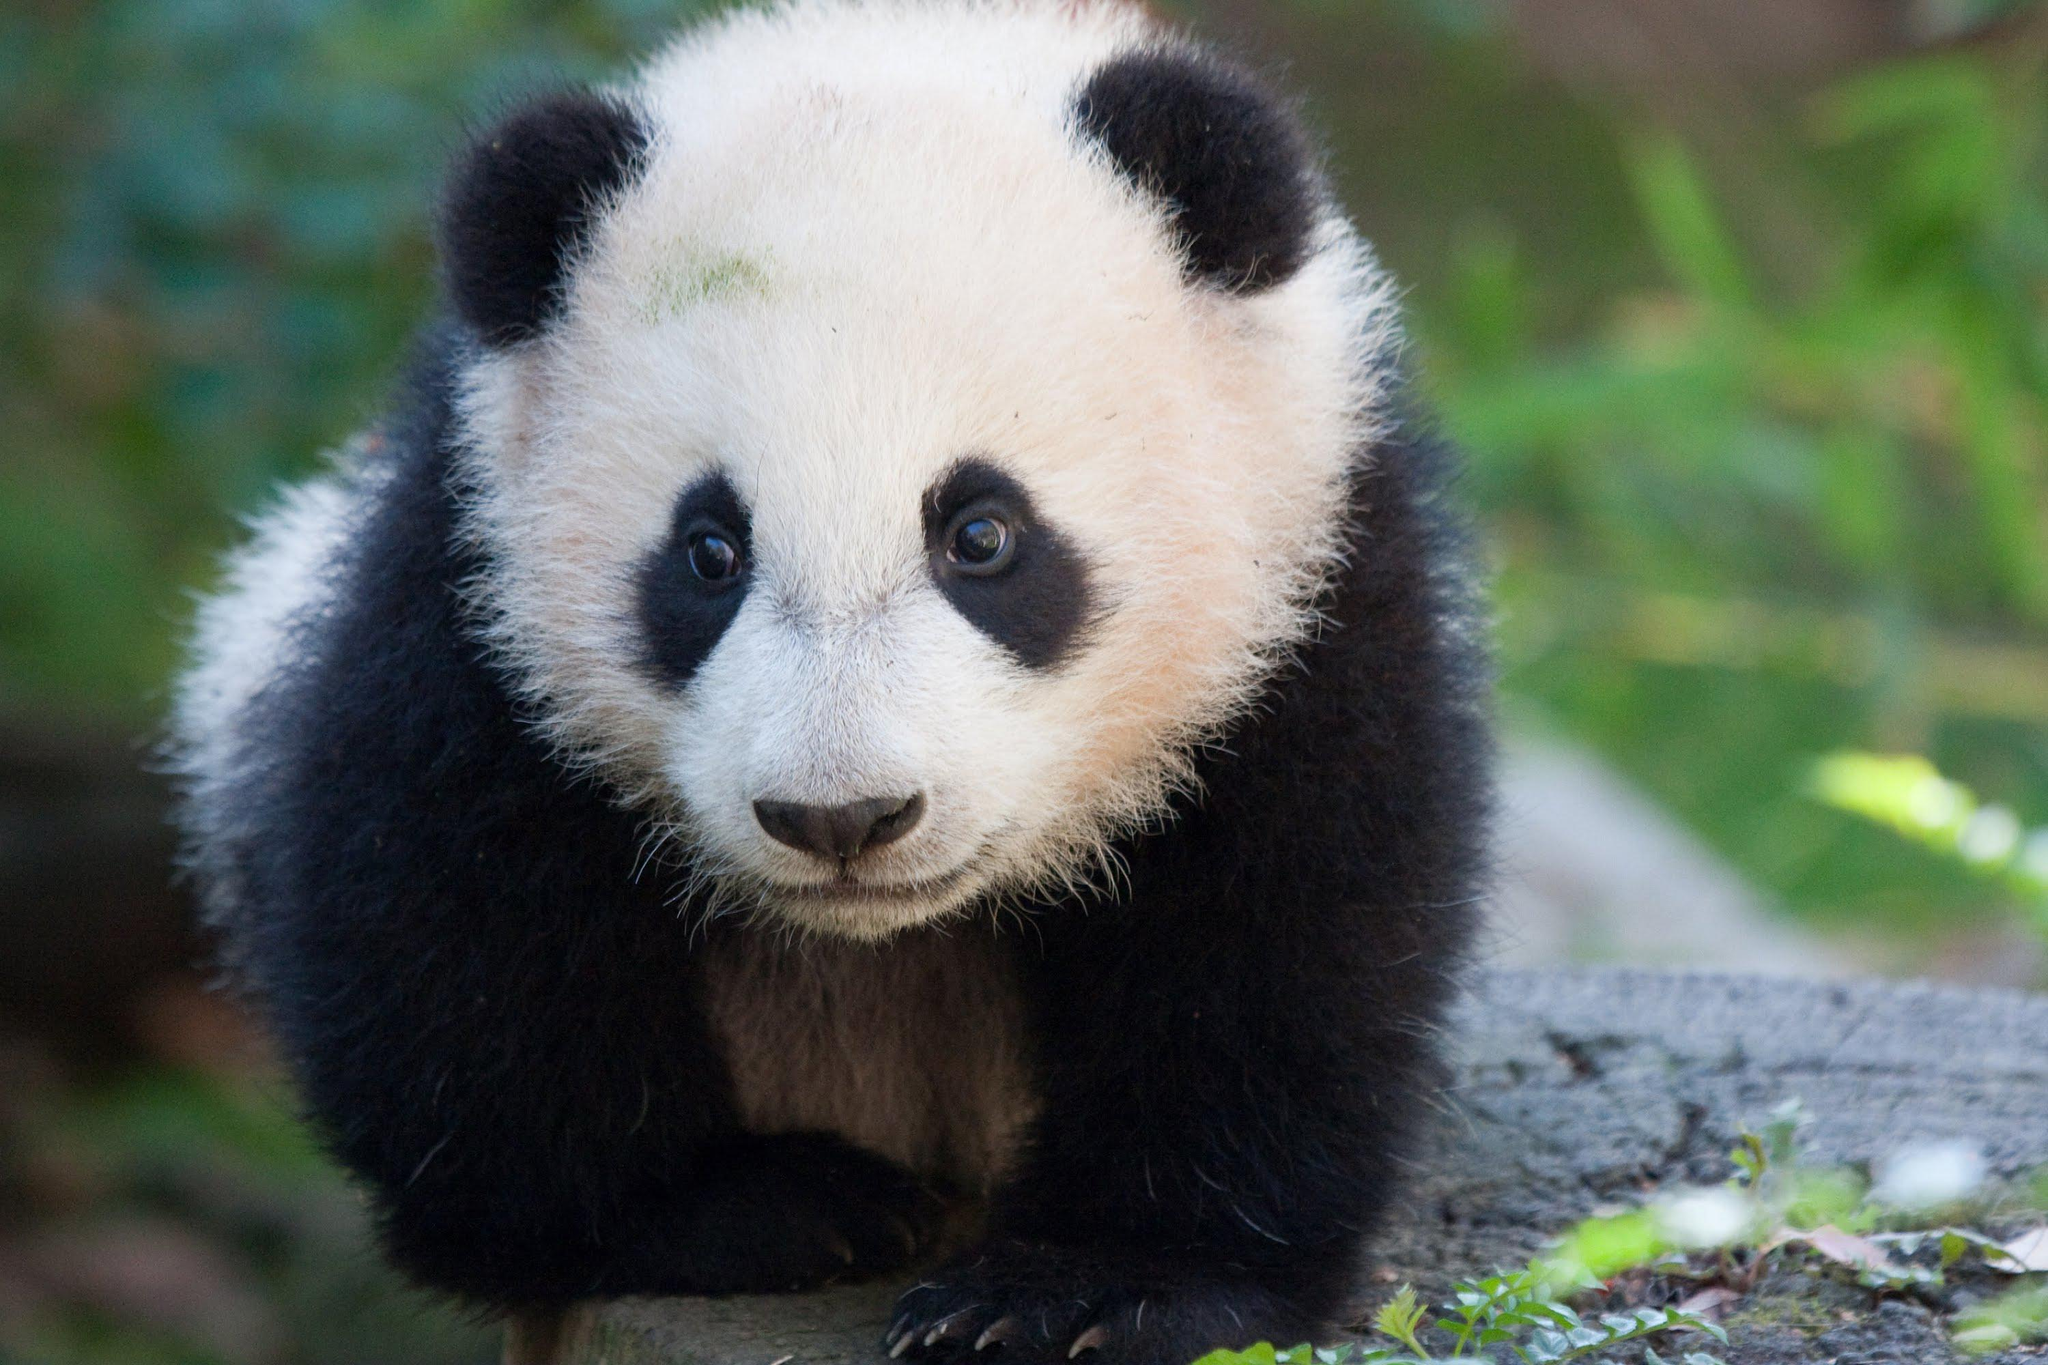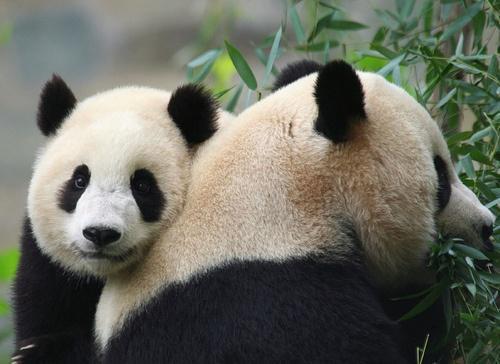The first image is the image on the left, the second image is the image on the right. For the images displayed, is the sentence "The right image contains two pandas in close contact." factually correct? Answer yes or no. Yes. The first image is the image on the left, the second image is the image on the right. Analyze the images presented: Is the assertion "There is at least one pair of pandas hugging." valid? Answer yes or no. Yes. 